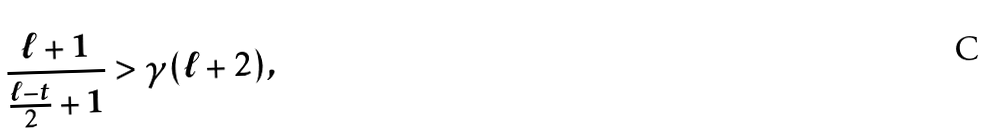<formula> <loc_0><loc_0><loc_500><loc_500>\frac { \ell + 1 } { \frac { \ell - t } { 2 } + 1 } > \gamma ( \ell + 2 ) ,</formula> 